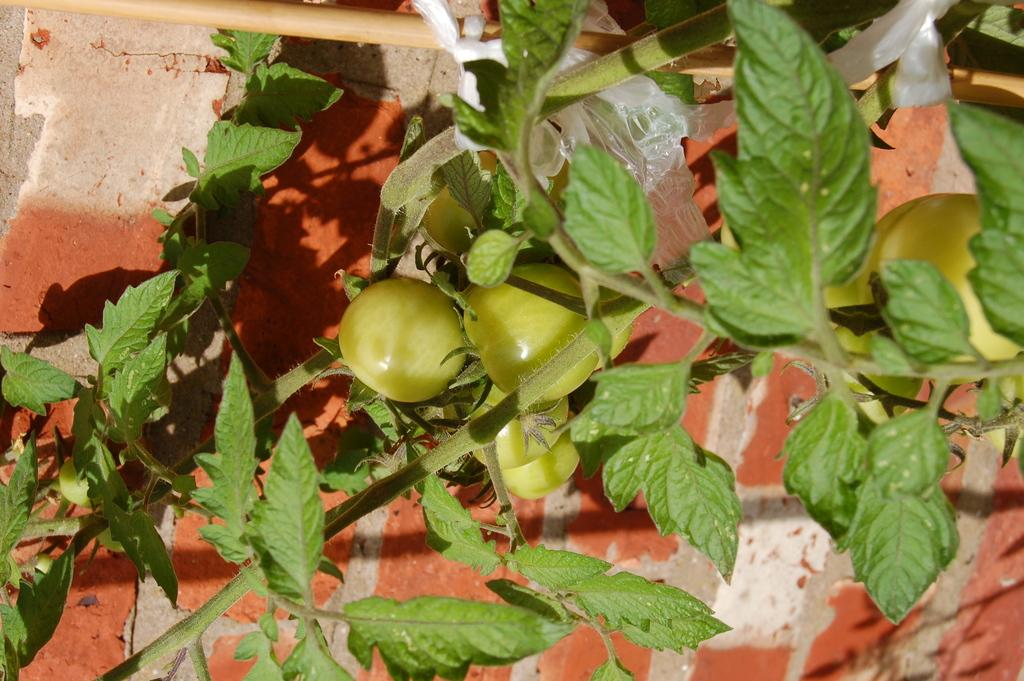What type of plant is in the image? There is a vegetable plant in the image. What is the vegetable plant positioned in front of? The vegetable plant is in front of a brick wall. What scent can be detected from the pickle in the image? There is no pickle present in the image, so no scent can be detected from it. 